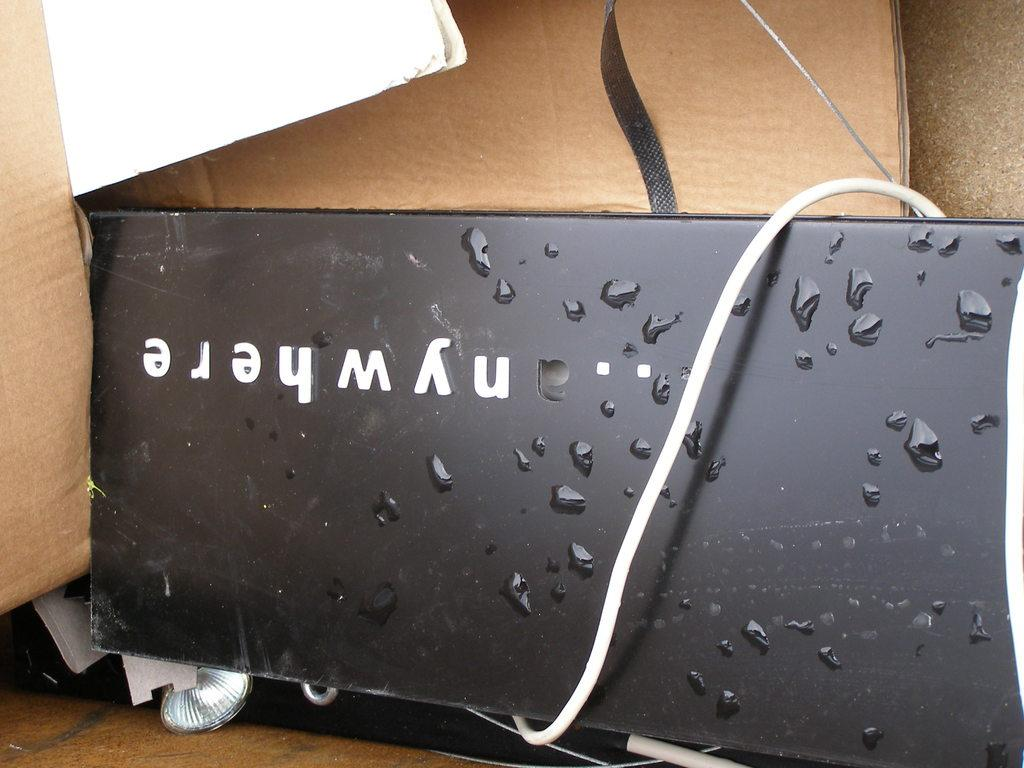<image>
Describe the image concisely. The side of a black box bears the name nywhere. 